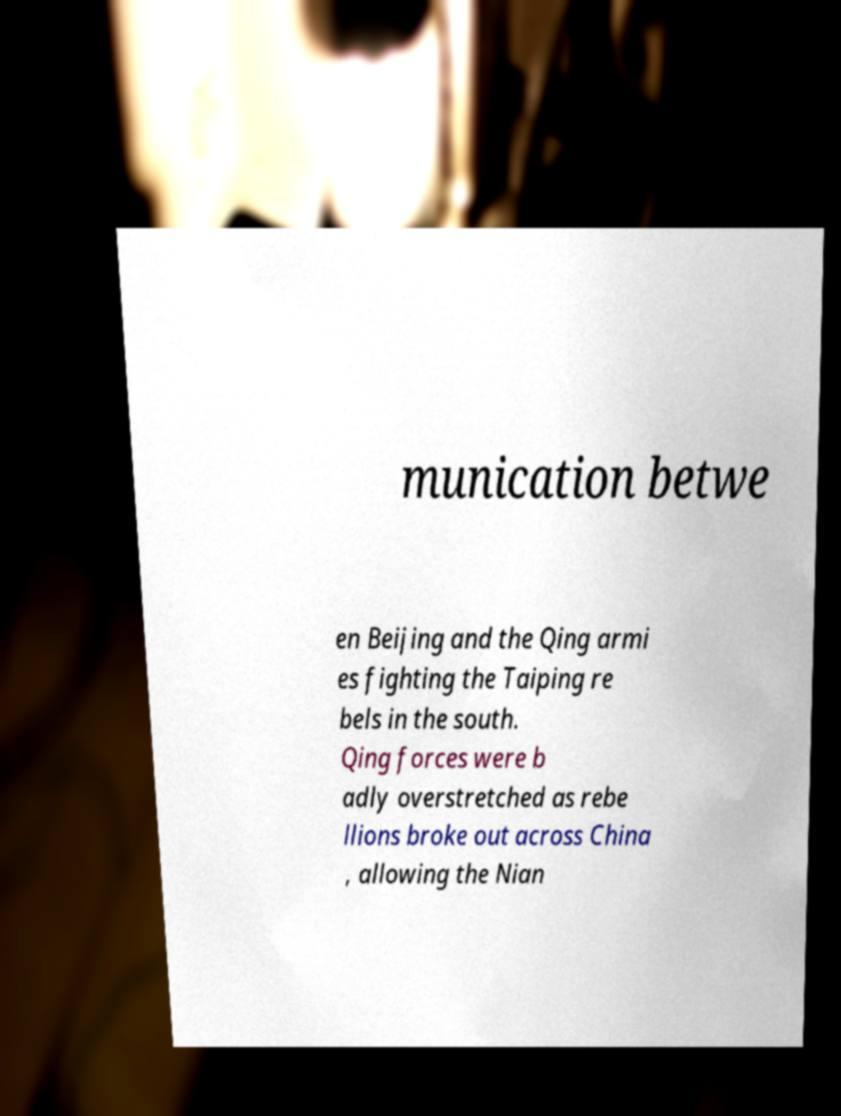There's text embedded in this image that I need extracted. Can you transcribe it verbatim? munication betwe en Beijing and the Qing armi es fighting the Taiping re bels in the south. Qing forces were b adly overstretched as rebe llions broke out across China , allowing the Nian 